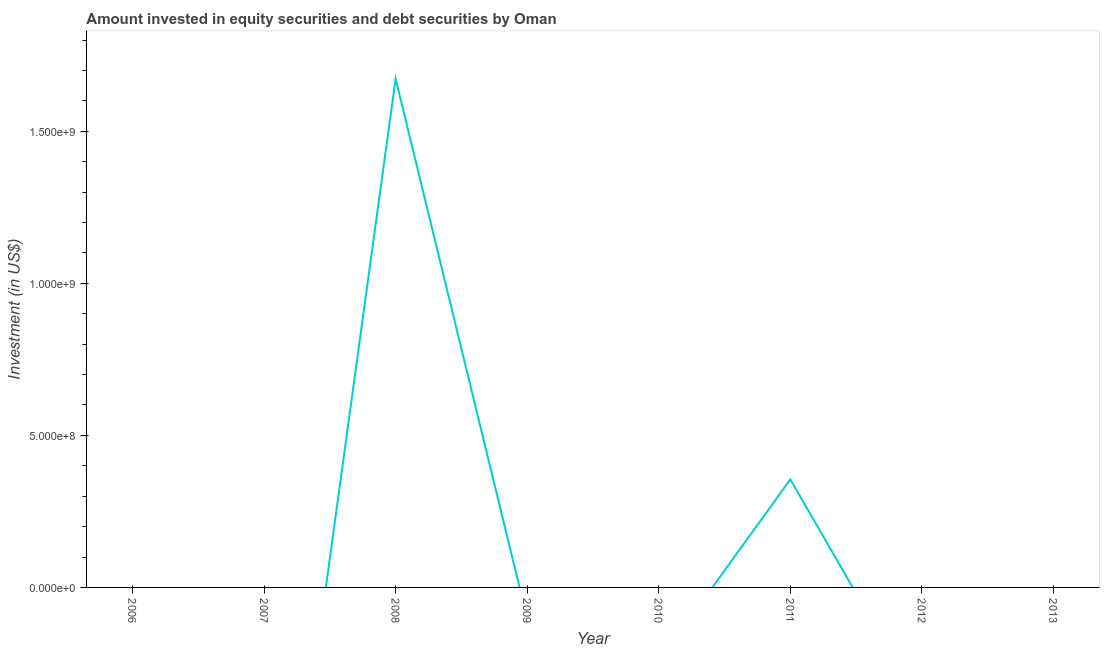What is the portfolio investment in 2007?
Ensure brevity in your answer.  0. Across all years, what is the maximum portfolio investment?
Your answer should be compact. 1.67e+09. In which year was the portfolio investment maximum?
Your answer should be very brief. 2008. What is the sum of the portfolio investment?
Ensure brevity in your answer.  2.03e+09. What is the difference between the portfolio investment in 2008 and 2011?
Offer a terse response. 1.32e+09. What is the average portfolio investment per year?
Make the answer very short. 2.54e+08. What is the median portfolio investment?
Give a very brief answer. 0. In how many years, is the portfolio investment greater than 1500000000 US$?
Make the answer very short. 1. What is the difference between the highest and the lowest portfolio investment?
Provide a succinct answer. 1.67e+09. In how many years, is the portfolio investment greater than the average portfolio investment taken over all years?
Make the answer very short. 2. Does the portfolio investment monotonically increase over the years?
Make the answer very short. No. How many years are there in the graph?
Provide a succinct answer. 8. What is the difference between two consecutive major ticks on the Y-axis?
Your response must be concise. 5.00e+08. What is the title of the graph?
Give a very brief answer. Amount invested in equity securities and debt securities by Oman. What is the label or title of the X-axis?
Ensure brevity in your answer.  Year. What is the label or title of the Y-axis?
Keep it short and to the point. Investment (in US$). What is the Investment (in US$) of 2007?
Offer a terse response. 0. What is the Investment (in US$) of 2008?
Keep it short and to the point. 1.67e+09. What is the Investment (in US$) in 2009?
Offer a terse response. 0. What is the Investment (in US$) of 2011?
Provide a succinct answer. 3.55e+08. What is the Investment (in US$) of 2012?
Your response must be concise. 0. What is the difference between the Investment (in US$) in 2008 and 2011?
Your answer should be very brief. 1.32e+09. What is the ratio of the Investment (in US$) in 2008 to that in 2011?
Provide a succinct answer. 4.71. 